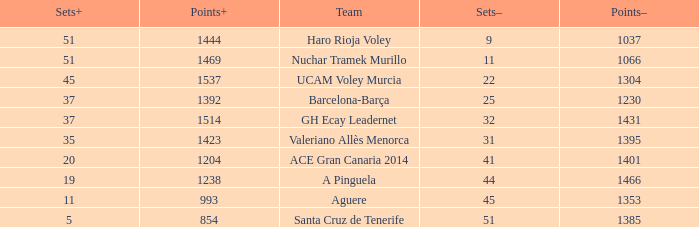Help me parse the entirety of this table. {'header': ['Sets+', 'Points+', 'Team', 'Sets–', 'Points–'], 'rows': [['51', '1444', 'Haro Rioja Voley', '9', '1037'], ['51', '1469', 'Nuchar Tramek Murillo', '11', '1066'], ['45', '1537', 'UCAM Voley Murcia', '22', '1304'], ['37', '1392', 'Barcelona-Barça', '25', '1230'], ['37', '1514', 'GH Ecay Leadernet', '32', '1431'], ['35', '1423', 'Valeriano Allès Menorca', '31', '1395'], ['20', '1204', 'ACE Gran Canaria 2014', '41', '1401'], ['19', '1238', 'A Pinguela', '44', '1466'], ['11', '993', 'Aguere', '45', '1353'], ['5', '854', 'Santa Cruz de Tenerife', '51', '1385']]} What is the highest Points+ number that has a Sets+ number larger than 45, a Sets- number larger than 9, and a Points- number smaller than 1066? None. 